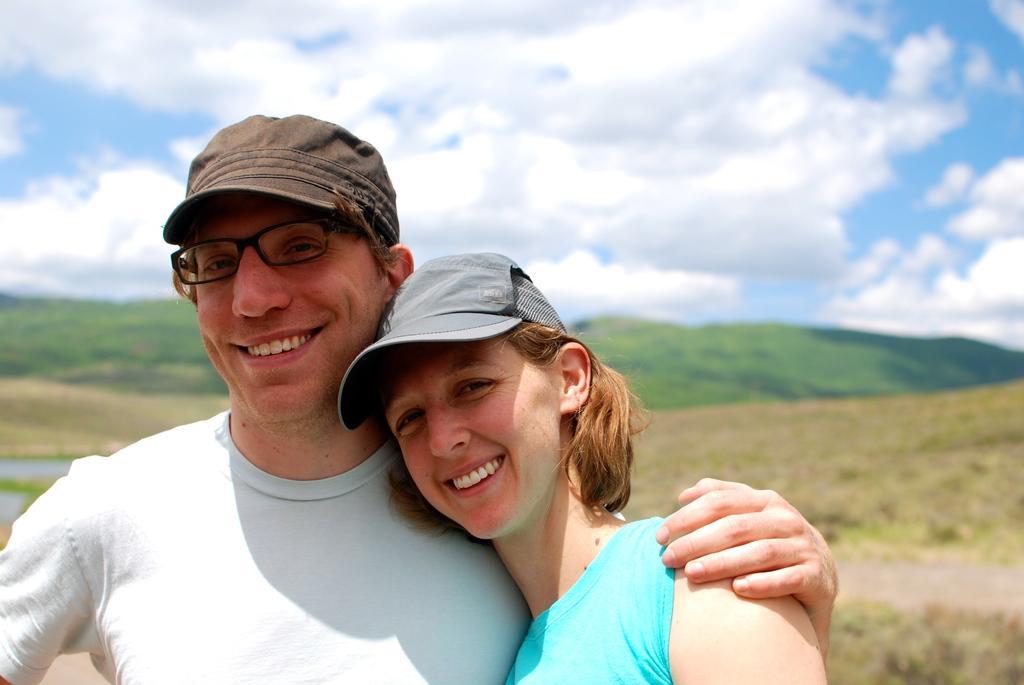Can you describe this image briefly? In the image I can see a lady and a guy who are wearing the caps and also I can see some mountains, trees and the cloudy sky. 